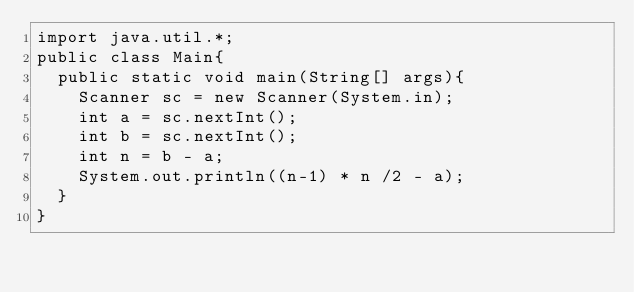Convert code to text. <code><loc_0><loc_0><loc_500><loc_500><_Java_>import java.util.*;
public class Main{
  public static void main(String[] args){
    Scanner sc = new Scanner(System.in);
    int a = sc.nextInt();
    int b = sc.nextInt();
    int n = b - a;
    System.out.println((n-1) * n /2 - a);
  }
}</code> 